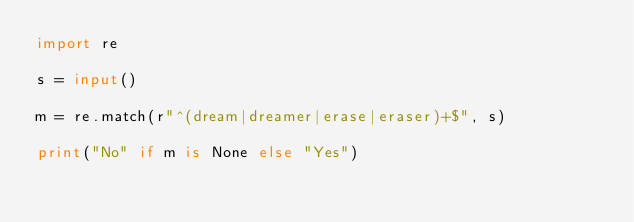Convert code to text. <code><loc_0><loc_0><loc_500><loc_500><_Python_>import re

s = input()

m = re.match(r"^(dream|dreamer|erase|eraser)+$", s)

print("No" if m is None else "Yes")</code> 